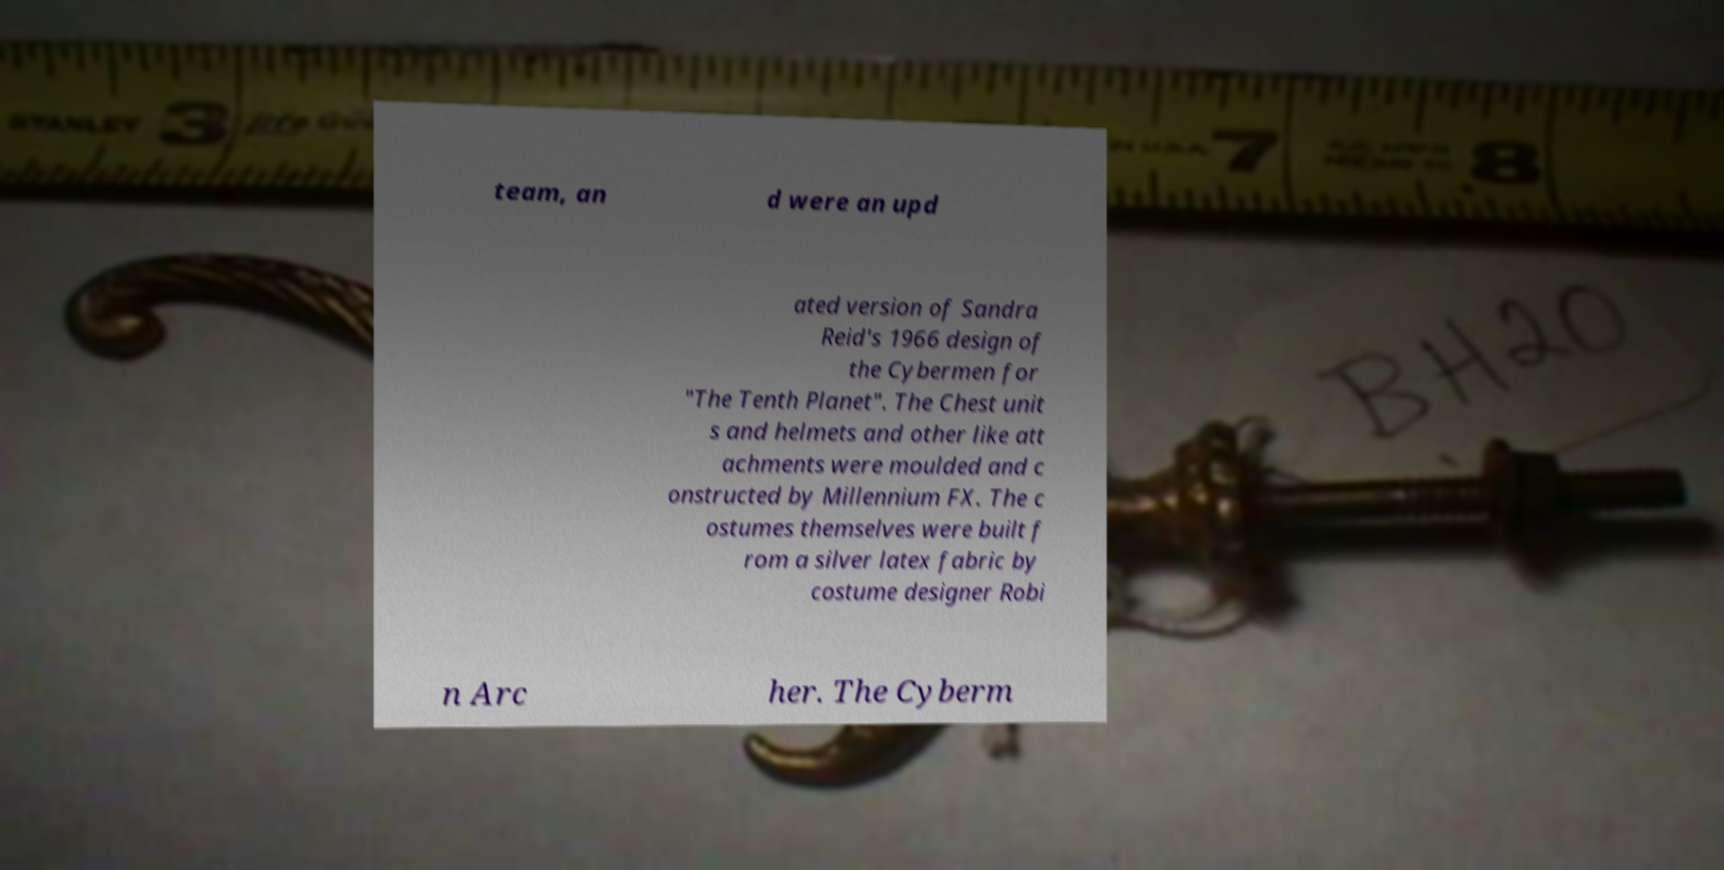Can you read and provide the text displayed in the image?This photo seems to have some interesting text. Can you extract and type it out for me? team, an d were an upd ated version of Sandra Reid's 1966 design of the Cybermen for "The Tenth Planet". The Chest unit s and helmets and other like att achments were moulded and c onstructed by Millennium FX. The c ostumes themselves were built f rom a silver latex fabric by costume designer Robi n Arc her. The Cyberm 